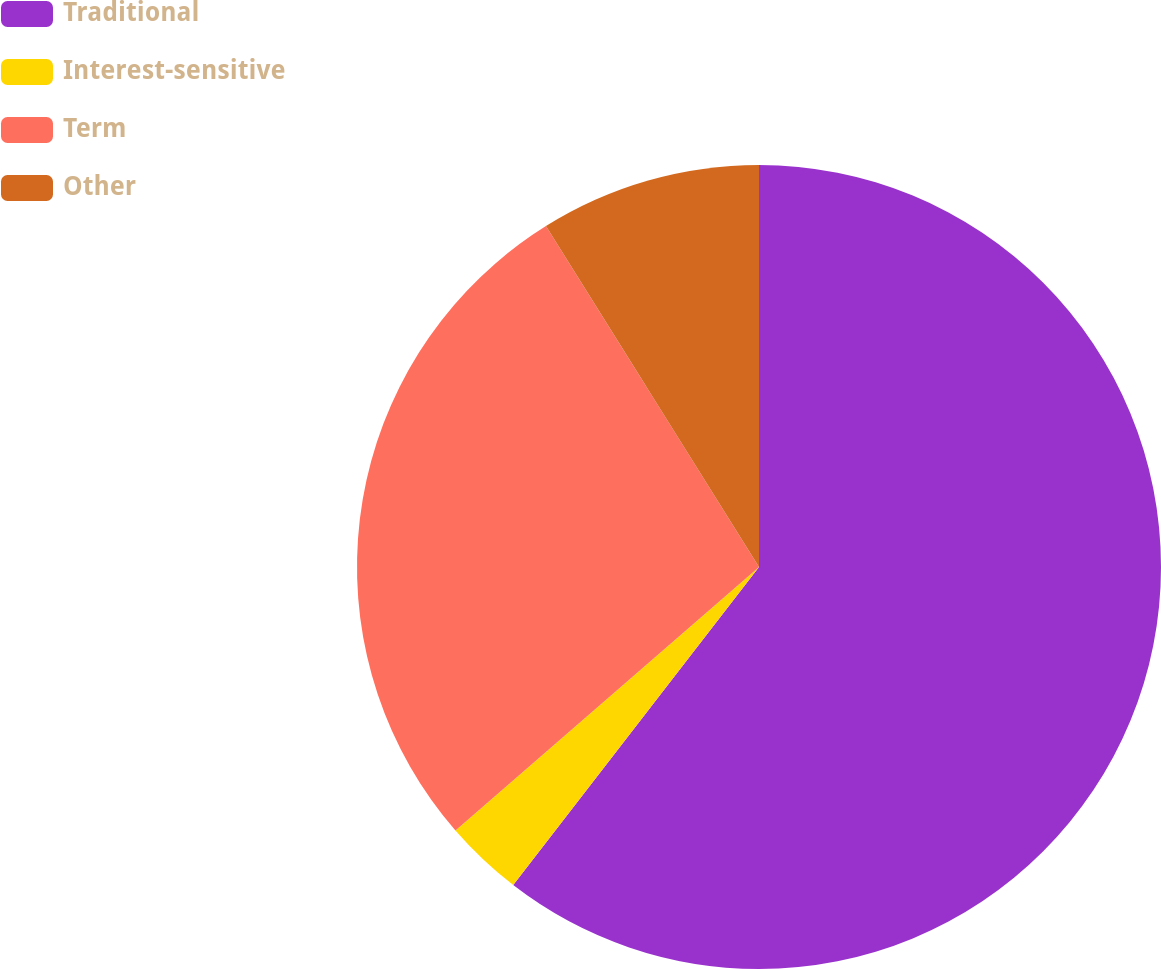Convert chart. <chart><loc_0><loc_0><loc_500><loc_500><pie_chart><fcel>Traditional<fcel>Interest-sensitive<fcel>Term<fcel>Other<nl><fcel>60.47%<fcel>3.15%<fcel>27.49%<fcel>8.89%<nl></chart> 